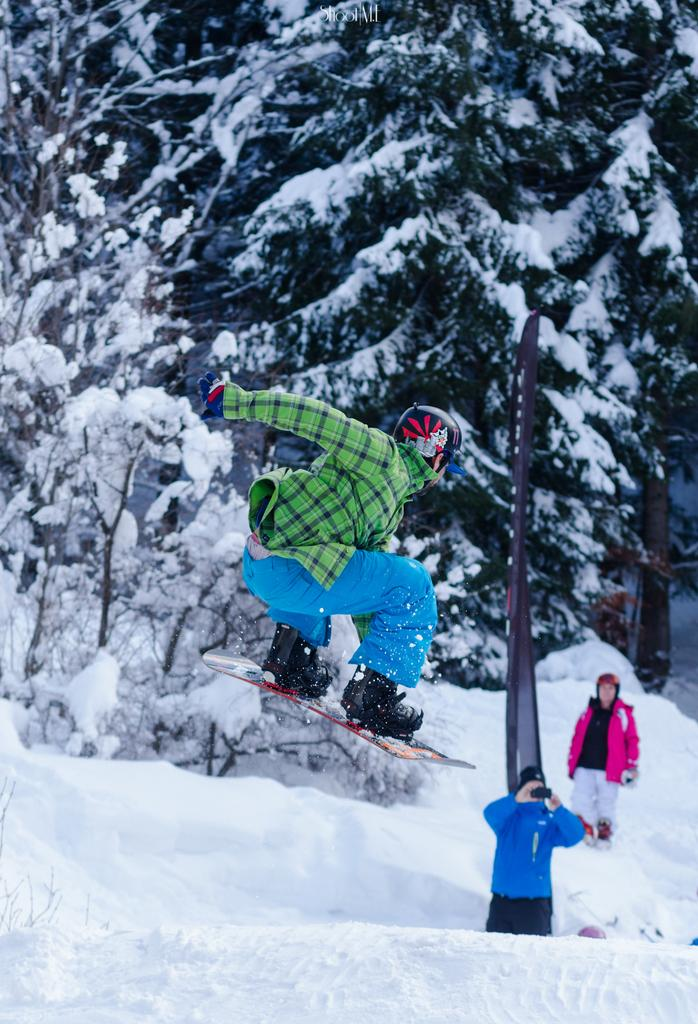How many people are in the image? There are two persons in the image. What is one person doing in the image? One person is skating. What is the other person holding in the image? One person is holding a mobile. What type of shoes is the skater wearing? The skater is wearing skating shoes. What protective gear is the skater wearing? The skater is wearing a helmet. What can be seen in the background of the image? There is a hill, snow, and trees in the background of the image. What type of care does the skater need after falling in the image? There is no indication in the image that the skater has fallen, so it is not possible to determine if they need any care. 